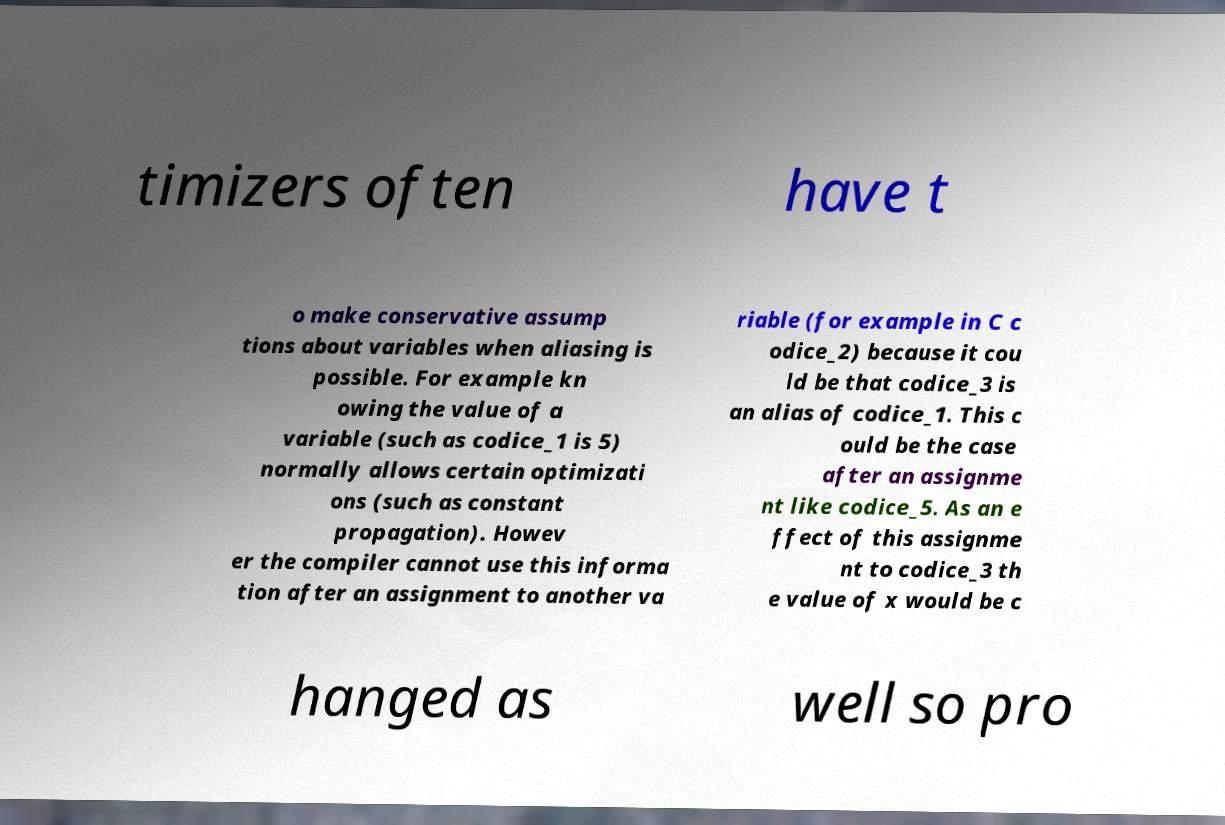Please read and relay the text visible in this image. What does it say? timizers often have t o make conservative assump tions about variables when aliasing is possible. For example kn owing the value of a variable (such as codice_1 is 5) normally allows certain optimizati ons (such as constant propagation). Howev er the compiler cannot use this informa tion after an assignment to another va riable (for example in C c odice_2) because it cou ld be that codice_3 is an alias of codice_1. This c ould be the case after an assignme nt like codice_5. As an e ffect of this assignme nt to codice_3 th e value of x would be c hanged as well so pro 